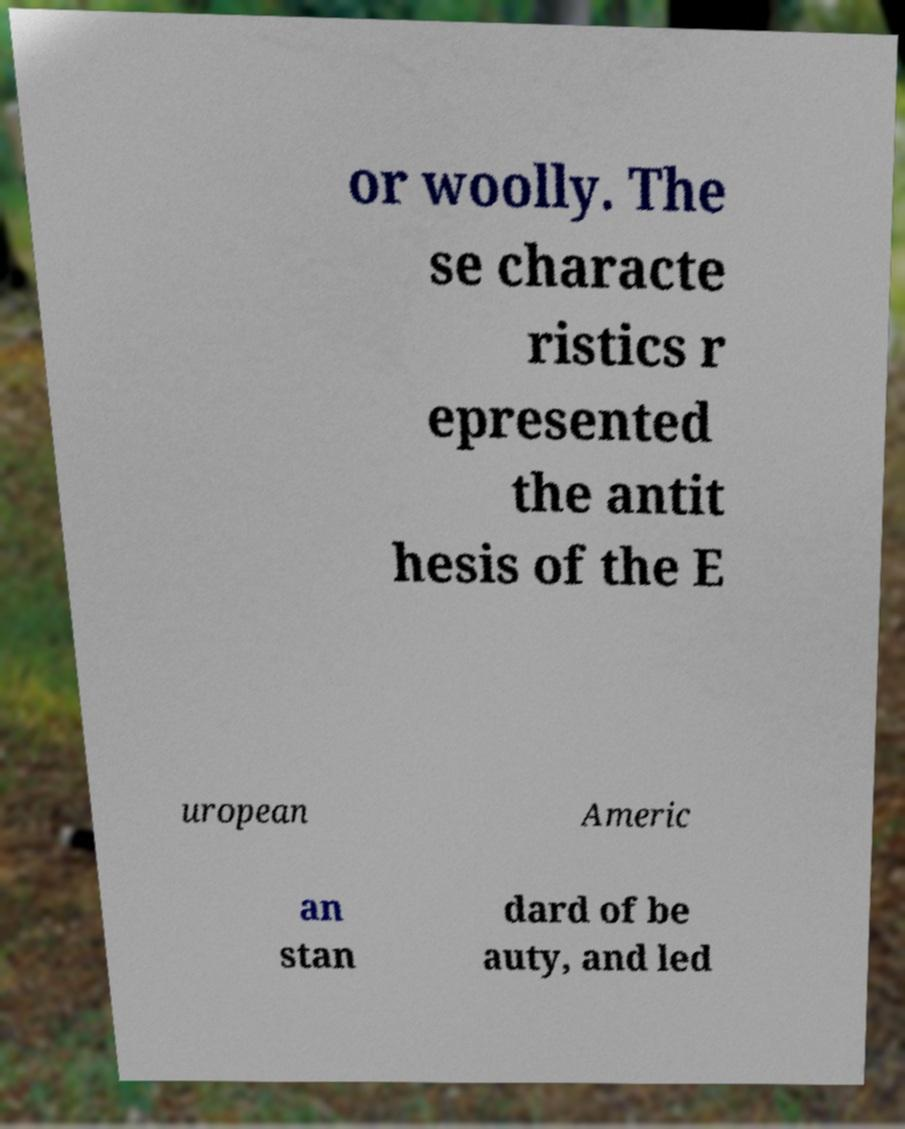There's text embedded in this image that I need extracted. Can you transcribe it verbatim? or woolly. The se characte ristics r epresented the antit hesis of the E uropean Americ an stan dard of be auty, and led 